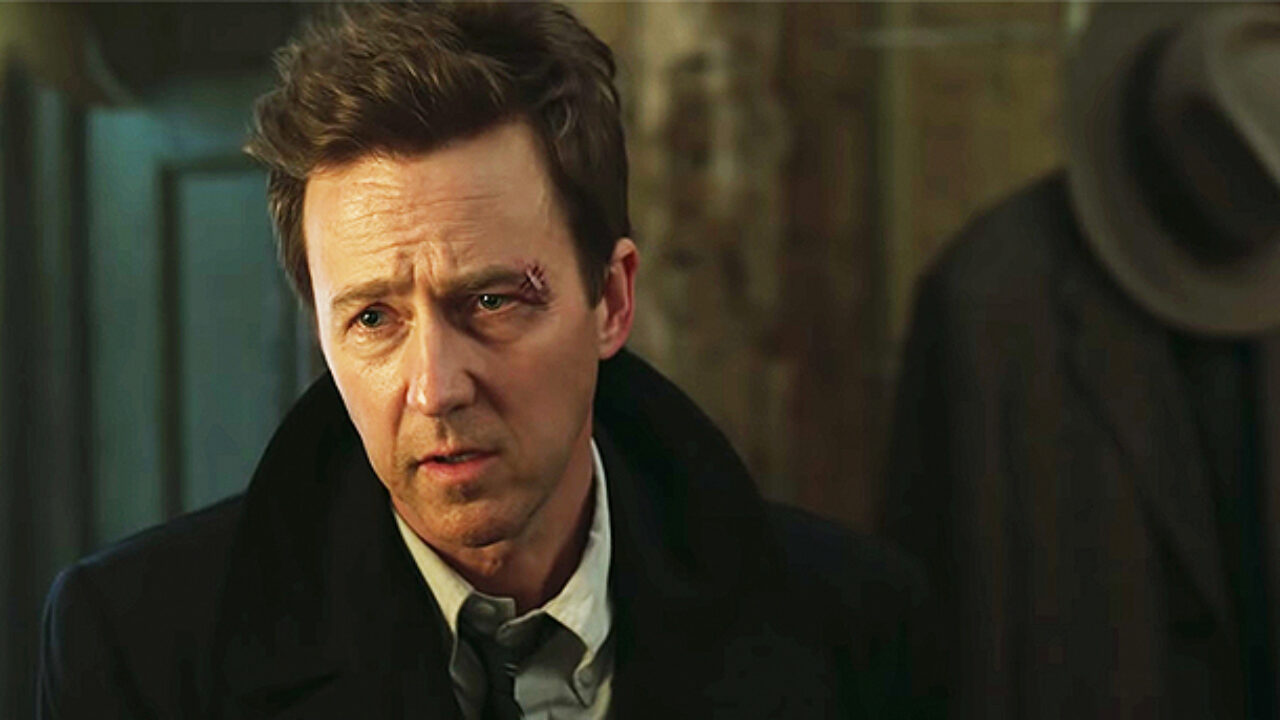If this scene were part of a surreal dream, what could be happening? In a surreal dream, this scene could depict the individual as a time-traveling detective who just stumbled upon a hidden chamber filled with enigmatic artifacts from various eras. The concerned look on his face results from deciphering a cryptic message that warns of an impending temporal collapse, threatening to erase significant moments in history. The dimly lit room symbolizes the passage of time, with shadows representing lost memories. The hat rack transforms into a portal allowing him to peak into different time periods. In the dream, he must solve the puzzle before time unravels, making this single moment a pivotal crossroad in his dreamscape adventure. What's an everyday scenario that could lead to the expression shown in the image? An everyday scenario that could lead to this expression might be a person coming home after a long day at work and finding a troubling letter in the mail. The formal suit indicates he just returned from the office, while the concerned expression and disheveled hair suggest a sudden rush of stress. The letter might contain an unexpected bill, news about a loved one, or issues at work, catching him off guard and leading to this moment of worry as depicted in the image. 